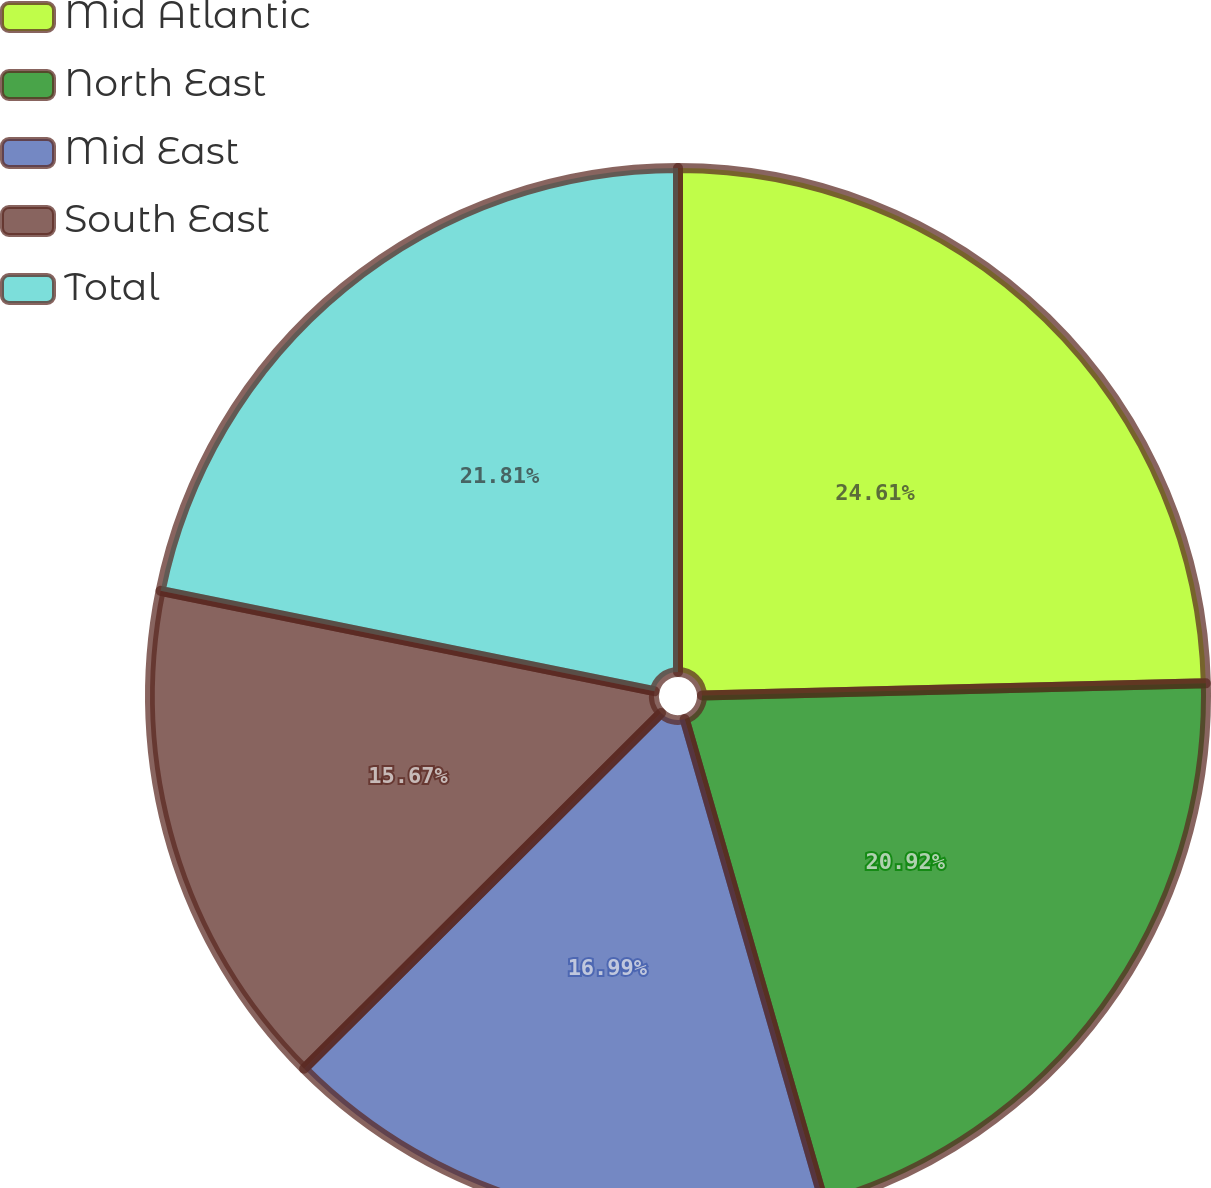Convert chart. <chart><loc_0><loc_0><loc_500><loc_500><pie_chart><fcel>Mid Atlantic<fcel>North East<fcel>Mid East<fcel>South East<fcel>Total<nl><fcel>24.62%<fcel>20.92%<fcel>16.99%<fcel>15.67%<fcel>21.81%<nl></chart> 